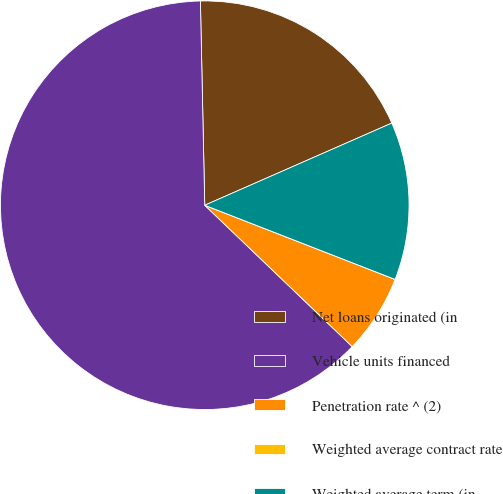<chart> <loc_0><loc_0><loc_500><loc_500><pie_chart><fcel>Net loans originated (in<fcel>Vehicle units financed<fcel>Penetration rate ^ (2)<fcel>Weighted average contract rate<fcel>Weighted average term (in<nl><fcel>18.75%<fcel>62.49%<fcel>6.25%<fcel>0.0%<fcel>12.5%<nl></chart> 